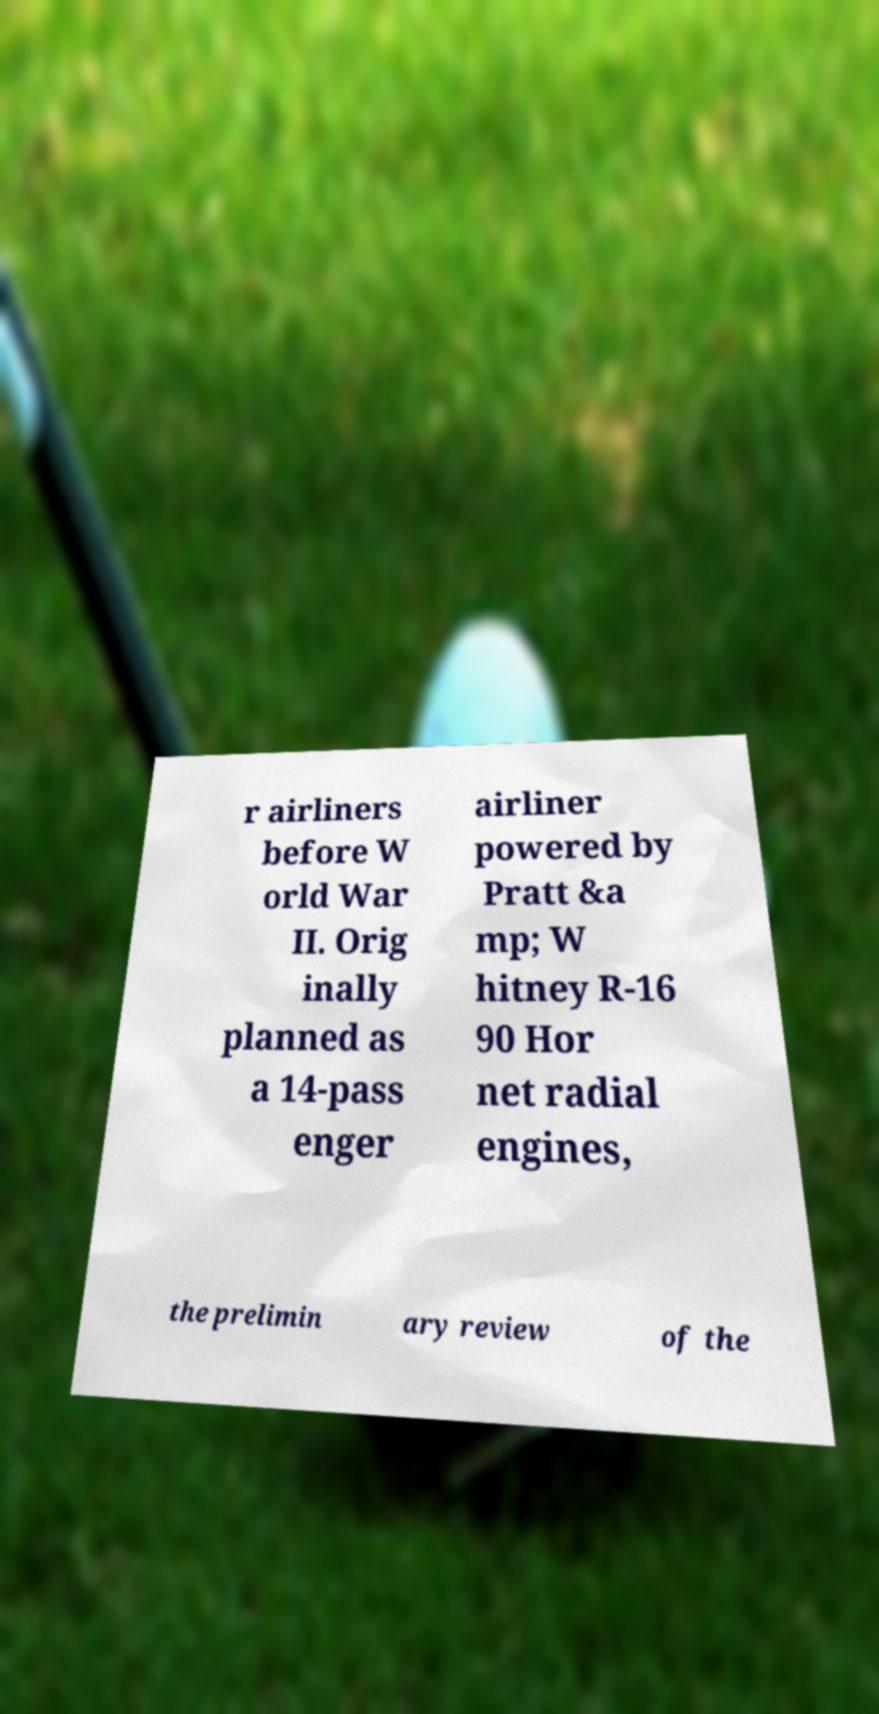Can you read and provide the text displayed in the image?This photo seems to have some interesting text. Can you extract and type it out for me? r airliners before W orld War II. Orig inally planned as a 14-pass enger airliner powered by Pratt &a mp; W hitney R-16 90 Hor net radial engines, the prelimin ary review of the 